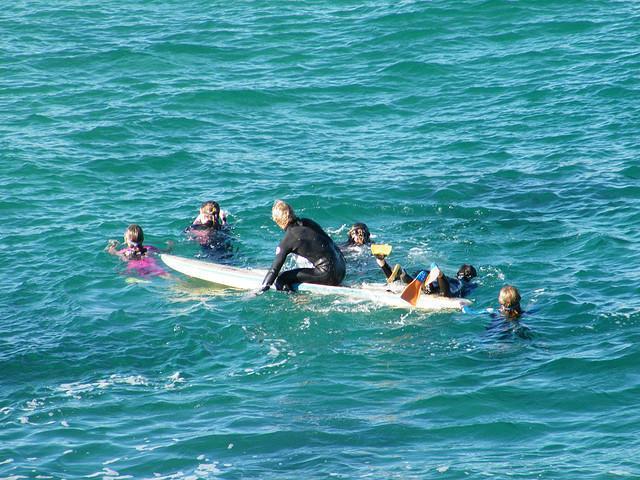How many people are in the water?
Give a very brief answer. 6. How many people are there?
Give a very brief answer. 2. How many motorcycles are in the picture?
Give a very brief answer. 0. 